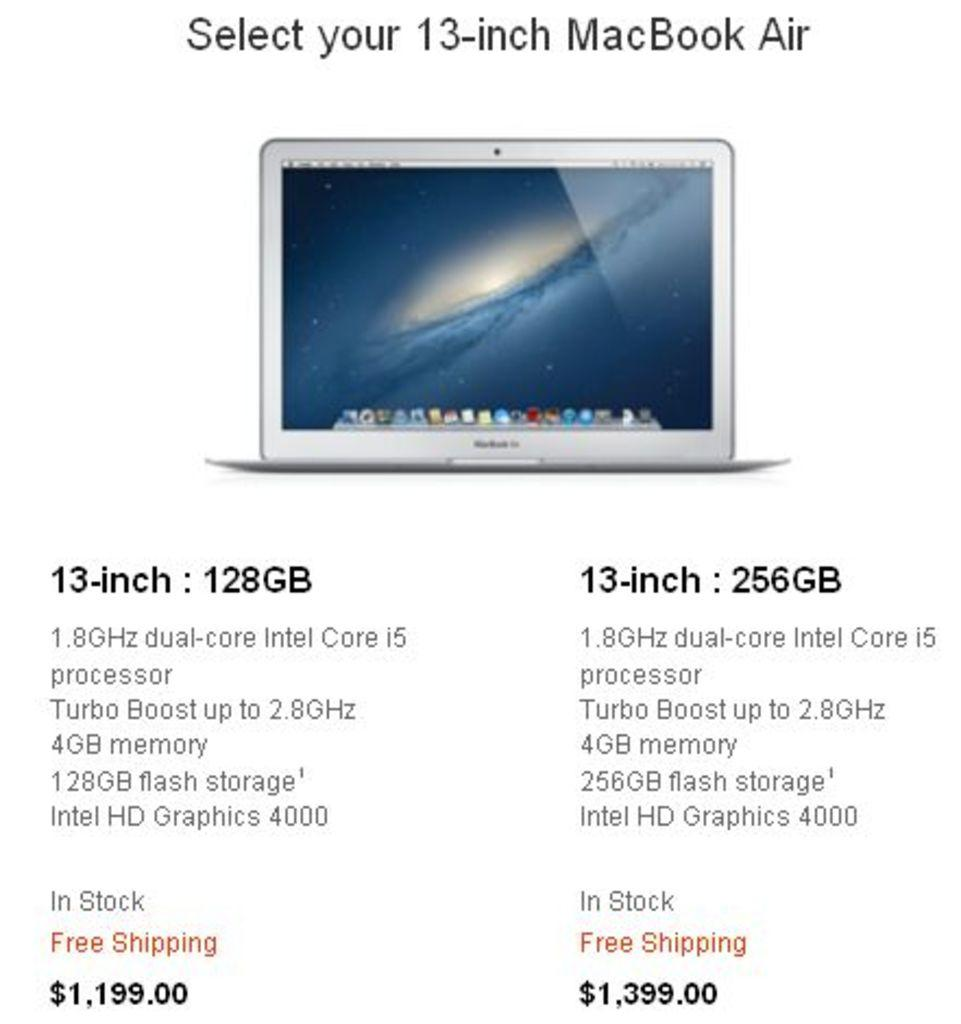<image>
Render a clear and concise summary of the photo. A comparison between two different 13 inch MacBook Air computers. 